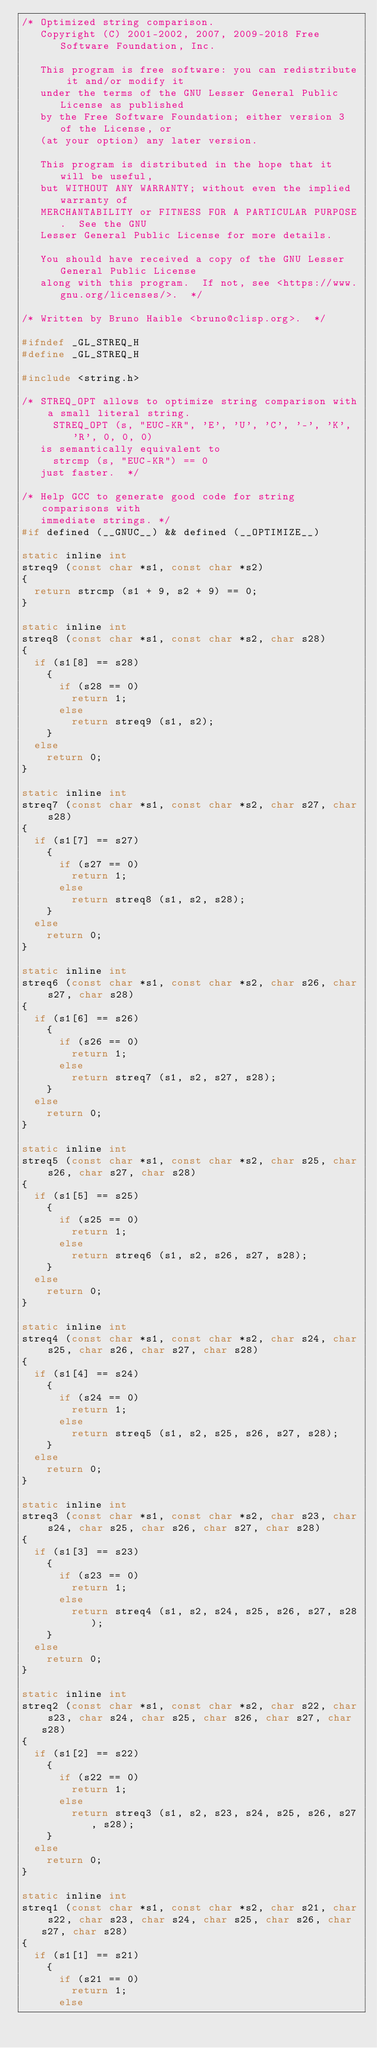<code> <loc_0><loc_0><loc_500><loc_500><_C_>/* Optimized string comparison.
   Copyright (C) 2001-2002, 2007, 2009-2018 Free Software Foundation, Inc.

   This program is free software: you can redistribute it and/or modify it
   under the terms of the GNU Lesser General Public License as published
   by the Free Software Foundation; either version 3 of the License, or
   (at your option) any later version.

   This program is distributed in the hope that it will be useful,
   but WITHOUT ANY WARRANTY; without even the implied warranty of
   MERCHANTABILITY or FITNESS FOR A PARTICULAR PURPOSE.  See the GNU
   Lesser General Public License for more details.

   You should have received a copy of the GNU Lesser General Public License
   along with this program.  If not, see <https://www.gnu.org/licenses/>.  */

/* Written by Bruno Haible <bruno@clisp.org>.  */

#ifndef _GL_STREQ_H
#define _GL_STREQ_H

#include <string.h>

/* STREQ_OPT allows to optimize string comparison with a small literal string.
     STREQ_OPT (s, "EUC-KR", 'E', 'U', 'C', '-', 'K', 'R', 0, 0, 0)
   is semantically equivalent to
     strcmp (s, "EUC-KR") == 0
   just faster.  */

/* Help GCC to generate good code for string comparisons with
   immediate strings. */
#if defined (__GNUC__) && defined (__OPTIMIZE__)

static inline int
streq9 (const char *s1, const char *s2)
{
  return strcmp (s1 + 9, s2 + 9) == 0;
}

static inline int
streq8 (const char *s1, const char *s2, char s28)
{
  if (s1[8] == s28)
    {
      if (s28 == 0)
        return 1;
      else
        return streq9 (s1, s2);
    }
  else
    return 0;
}

static inline int
streq7 (const char *s1, const char *s2, char s27, char s28)
{
  if (s1[7] == s27)
    {
      if (s27 == 0)
        return 1;
      else
        return streq8 (s1, s2, s28);
    }
  else
    return 0;
}

static inline int
streq6 (const char *s1, const char *s2, char s26, char s27, char s28)
{
  if (s1[6] == s26)
    {
      if (s26 == 0)
        return 1;
      else
        return streq7 (s1, s2, s27, s28);
    }
  else
    return 0;
}

static inline int
streq5 (const char *s1, const char *s2, char s25, char s26, char s27, char s28)
{
  if (s1[5] == s25)
    {
      if (s25 == 0)
        return 1;
      else
        return streq6 (s1, s2, s26, s27, s28);
    }
  else
    return 0;
}

static inline int
streq4 (const char *s1, const char *s2, char s24, char s25, char s26, char s27, char s28)
{
  if (s1[4] == s24)
    {
      if (s24 == 0)
        return 1;
      else
        return streq5 (s1, s2, s25, s26, s27, s28);
    }
  else
    return 0;
}

static inline int
streq3 (const char *s1, const char *s2, char s23, char s24, char s25, char s26, char s27, char s28)
{
  if (s1[3] == s23)
    {
      if (s23 == 0)
        return 1;
      else
        return streq4 (s1, s2, s24, s25, s26, s27, s28);
    }
  else
    return 0;
}

static inline int
streq2 (const char *s1, const char *s2, char s22, char s23, char s24, char s25, char s26, char s27, char s28)
{
  if (s1[2] == s22)
    {
      if (s22 == 0)
        return 1;
      else
        return streq3 (s1, s2, s23, s24, s25, s26, s27, s28);
    }
  else
    return 0;
}

static inline int
streq1 (const char *s1, const char *s2, char s21, char s22, char s23, char s24, char s25, char s26, char s27, char s28)
{
  if (s1[1] == s21)
    {
      if (s21 == 0)
        return 1;
      else</code> 